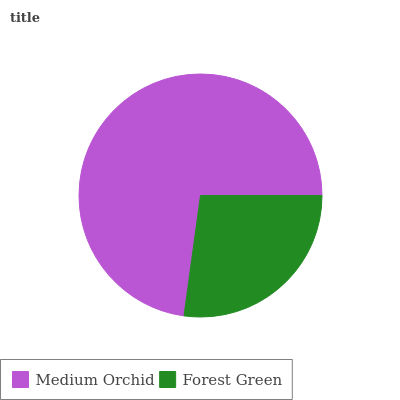Is Forest Green the minimum?
Answer yes or no. Yes. Is Medium Orchid the maximum?
Answer yes or no. Yes. Is Forest Green the maximum?
Answer yes or no. No. Is Medium Orchid greater than Forest Green?
Answer yes or no. Yes. Is Forest Green less than Medium Orchid?
Answer yes or no. Yes. Is Forest Green greater than Medium Orchid?
Answer yes or no. No. Is Medium Orchid less than Forest Green?
Answer yes or no. No. Is Medium Orchid the high median?
Answer yes or no. Yes. Is Forest Green the low median?
Answer yes or no. Yes. Is Forest Green the high median?
Answer yes or no. No. Is Medium Orchid the low median?
Answer yes or no. No. 